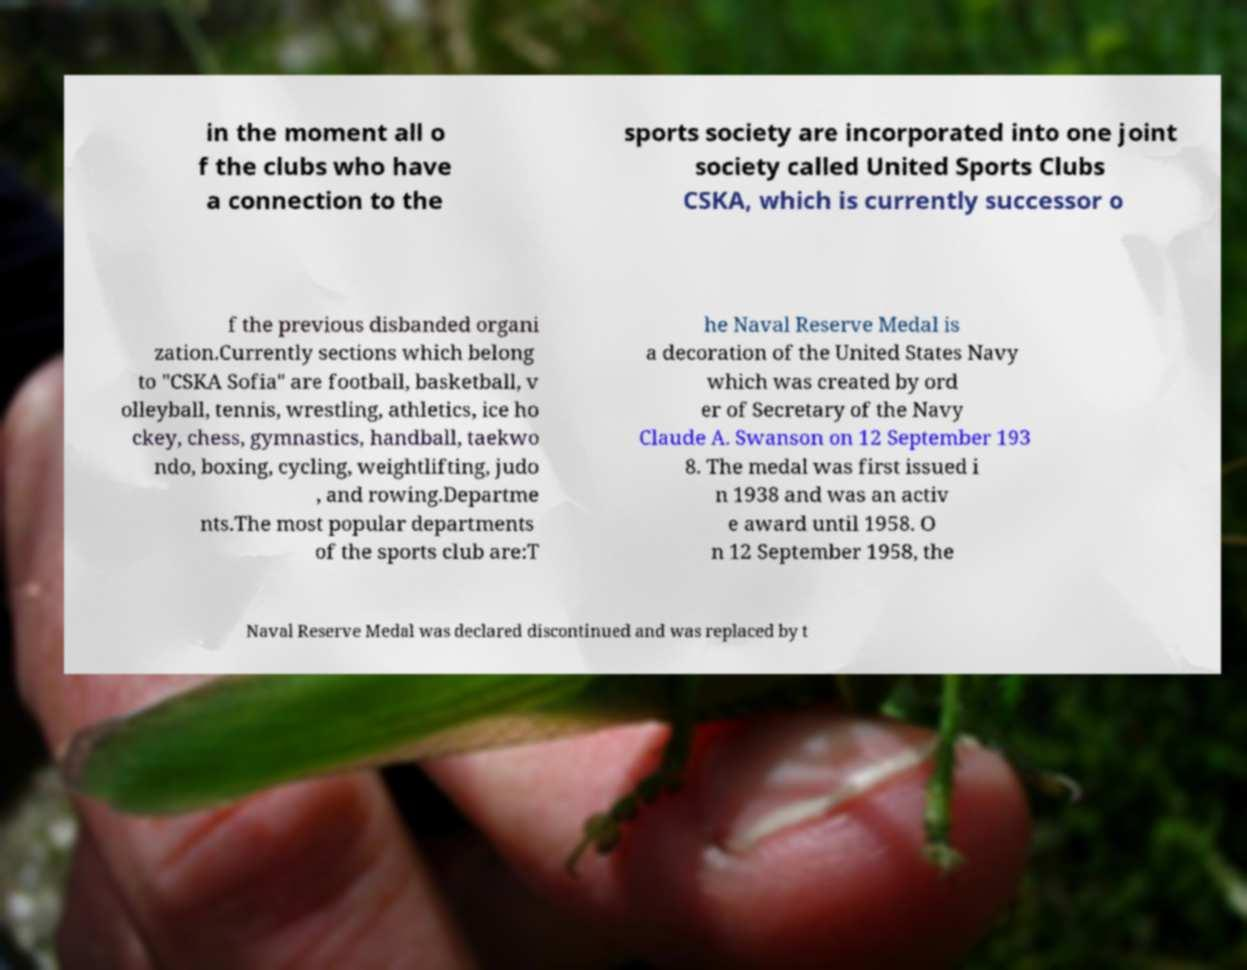Can you read and provide the text displayed in the image?This photo seems to have some interesting text. Can you extract and type it out for me? in the moment all o f the clubs who have a connection to the sports society are incorporated into one joint society called United Sports Clubs CSKA, which is currently successor o f the previous disbanded organi zation.Currently sections which belong to "CSKA Sofia" are football, basketball, v olleyball, tennis, wrestling, athletics, ice ho ckey, chess, gymnastics, handball, taekwo ndo, boxing, cycling, weightlifting, judo , and rowing.Departme nts.The most popular departments of the sports club are:T he Naval Reserve Medal is a decoration of the United States Navy which was created by ord er of Secretary of the Navy Claude A. Swanson on 12 September 193 8. The medal was first issued i n 1938 and was an activ e award until 1958. O n 12 September 1958, the Naval Reserve Medal was declared discontinued and was replaced by t 